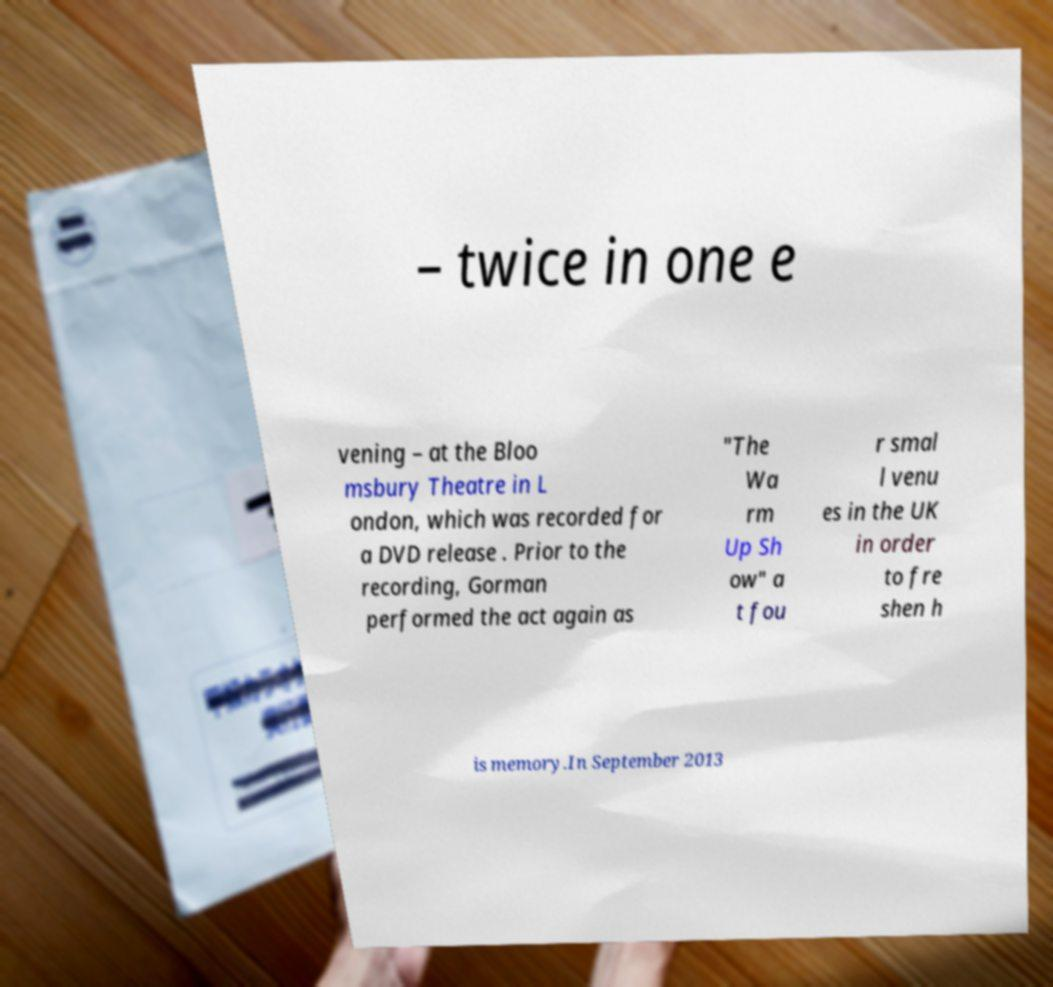Can you read and provide the text displayed in the image?This photo seems to have some interesting text. Can you extract and type it out for me? – twice in one e vening – at the Bloo msbury Theatre in L ondon, which was recorded for a DVD release . Prior to the recording, Gorman performed the act again as "The Wa rm Up Sh ow" a t fou r smal l venu es in the UK in order to fre shen h is memory.In September 2013 